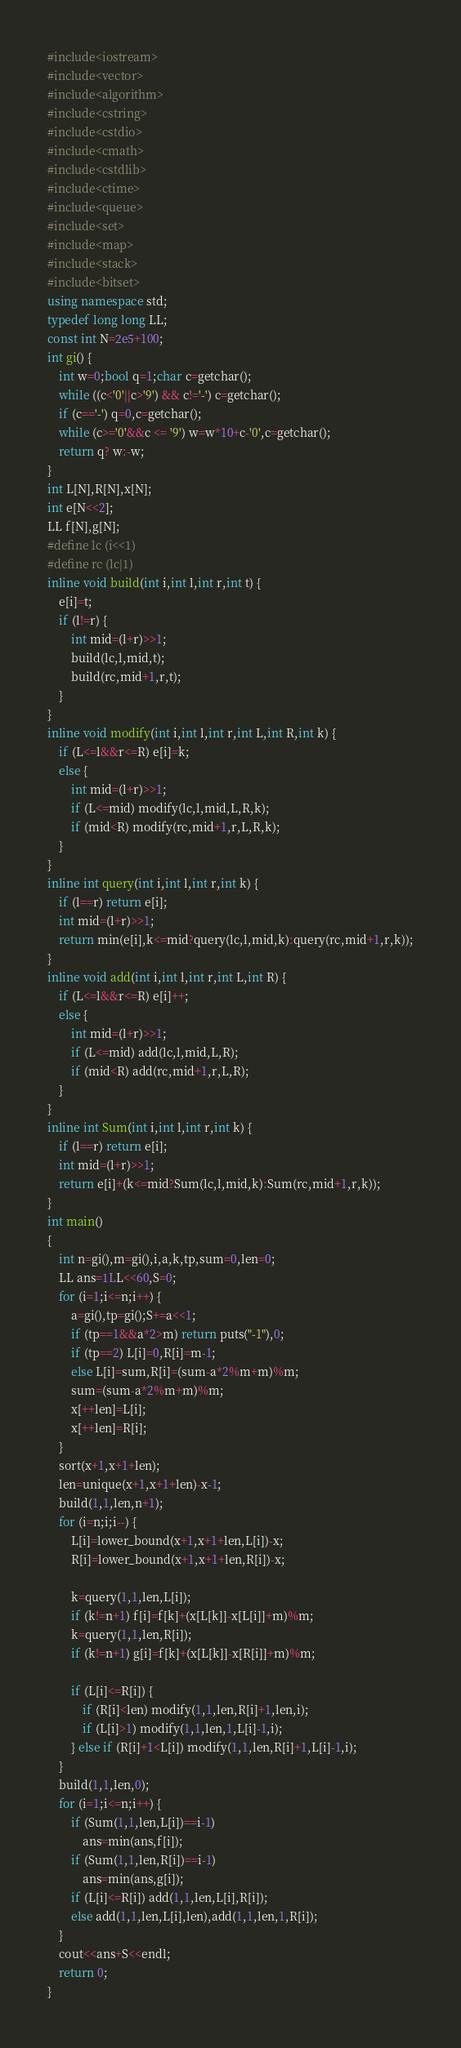Convert code to text. <code><loc_0><loc_0><loc_500><loc_500><_C++_>#include<iostream>
#include<vector>
#include<algorithm>
#include<cstring>
#include<cstdio>
#include<cmath>
#include<cstdlib>
#include<ctime>
#include<queue>
#include<set>
#include<map>
#include<stack>
#include<bitset>
using namespace std;
typedef long long LL;
const int N=2e5+100;
int gi() {
	int w=0;bool q=1;char c=getchar();
	while ((c<'0'||c>'9') && c!='-') c=getchar();
	if (c=='-') q=0,c=getchar();
	while (c>='0'&&c <= '9') w=w*10+c-'0',c=getchar();
	return q? w:-w;
}
int L[N],R[N],x[N];
int e[N<<2];
LL f[N],g[N];
#define lc (i<<1)
#define rc (lc|1)
inline void build(int i,int l,int r,int t) {
	e[i]=t;
	if (l!=r) {
		int mid=(l+r)>>1;
		build(lc,l,mid,t);
		build(rc,mid+1,r,t);
	}
}
inline void modify(int i,int l,int r,int L,int R,int k) {
	if (L<=l&&r<=R) e[i]=k;
	else {
		int mid=(l+r)>>1;
		if (L<=mid) modify(lc,l,mid,L,R,k);
		if (mid<R) modify(rc,mid+1,r,L,R,k);
	}
}
inline int query(int i,int l,int r,int k) {
	if (l==r) return e[i];
	int mid=(l+r)>>1;
	return min(e[i],k<=mid?query(lc,l,mid,k):query(rc,mid+1,r,k));
}
inline void add(int i,int l,int r,int L,int R) {
	if (L<=l&&r<=R) e[i]++;
	else {
		int mid=(l+r)>>1;
		if (L<=mid) add(lc,l,mid,L,R);
		if (mid<R) add(rc,mid+1,r,L,R);
	}
}
inline int Sum(int i,int l,int r,int k) {
	if (l==r) return e[i];
	int mid=(l+r)>>1;
	return e[i]+(k<=mid?Sum(lc,l,mid,k):Sum(rc,mid+1,r,k));
}
int main()
{
	int n=gi(),m=gi(),i,a,k,tp,sum=0,len=0;
	LL ans=1LL<<60,S=0;
	for (i=1;i<=n;i++) {
		a=gi(),tp=gi();S+=a<<1;
		if (tp==1&&a*2>m) return puts("-1"),0;
		if (tp==2) L[i]=0,R[i]=m-1;
		else L[i]=sum,R[i]=(sum-a*2%m+m)%m;
		sum=(sum-a*2%m+m)%m;
		x[++len]=L[i];
		x[++len]=R[i];
	}
	sort(x+1,x+1+len);
	len=unique(x+1,x+1+len)-x-1;
	build(1,1,len,n+1);
	for (i=n;i;i--) {
		L[i]=lower_bound(x+1,x+1+len,L[i])-x;
		R[i]=lower_bound(x+1,x+1+len,R[i])-x;

		k=query(1,1,len,L[i]);
		if (k!=n+1) f[i]=f[k]+(x[L[k]]-x[L[i]]+m)%m;
		k=query(1,1,len,R[i]);
		if (k!=n+1) g[i]=f[k]+(x[L[k]]-x[R[i]]+m)%m;

		if (L[i]<=R[i]) {
			if (R[i]<len) modify(1,1,len,R[i]+1,len,i);
			if (L[i]>1) modify(1,1,len,1,L[i]-1,i);
		} else if (R[i]+1<L[i]) modify(1,1,len,R[i]+1,L[i]-1,i);
	}
	build(1,1,len,0);
	for (i=1;i<=n;i++) {
		if (Sum(1,1,len,L[i])==i-1)
			ans=min(ans,f[i]);
		if (Sum(1,1,len,R[i])==i-1)
			ans=min(ans,g[i]);
		if (L[i]<=R[i]) add(1,1,len,L[i],R[i]);
		else add(1,1,len,L[i],len),add(1,1,len,1,R[i]);
	}
	cout<<ans+S<<endl;
	return 0;
}
</code> 